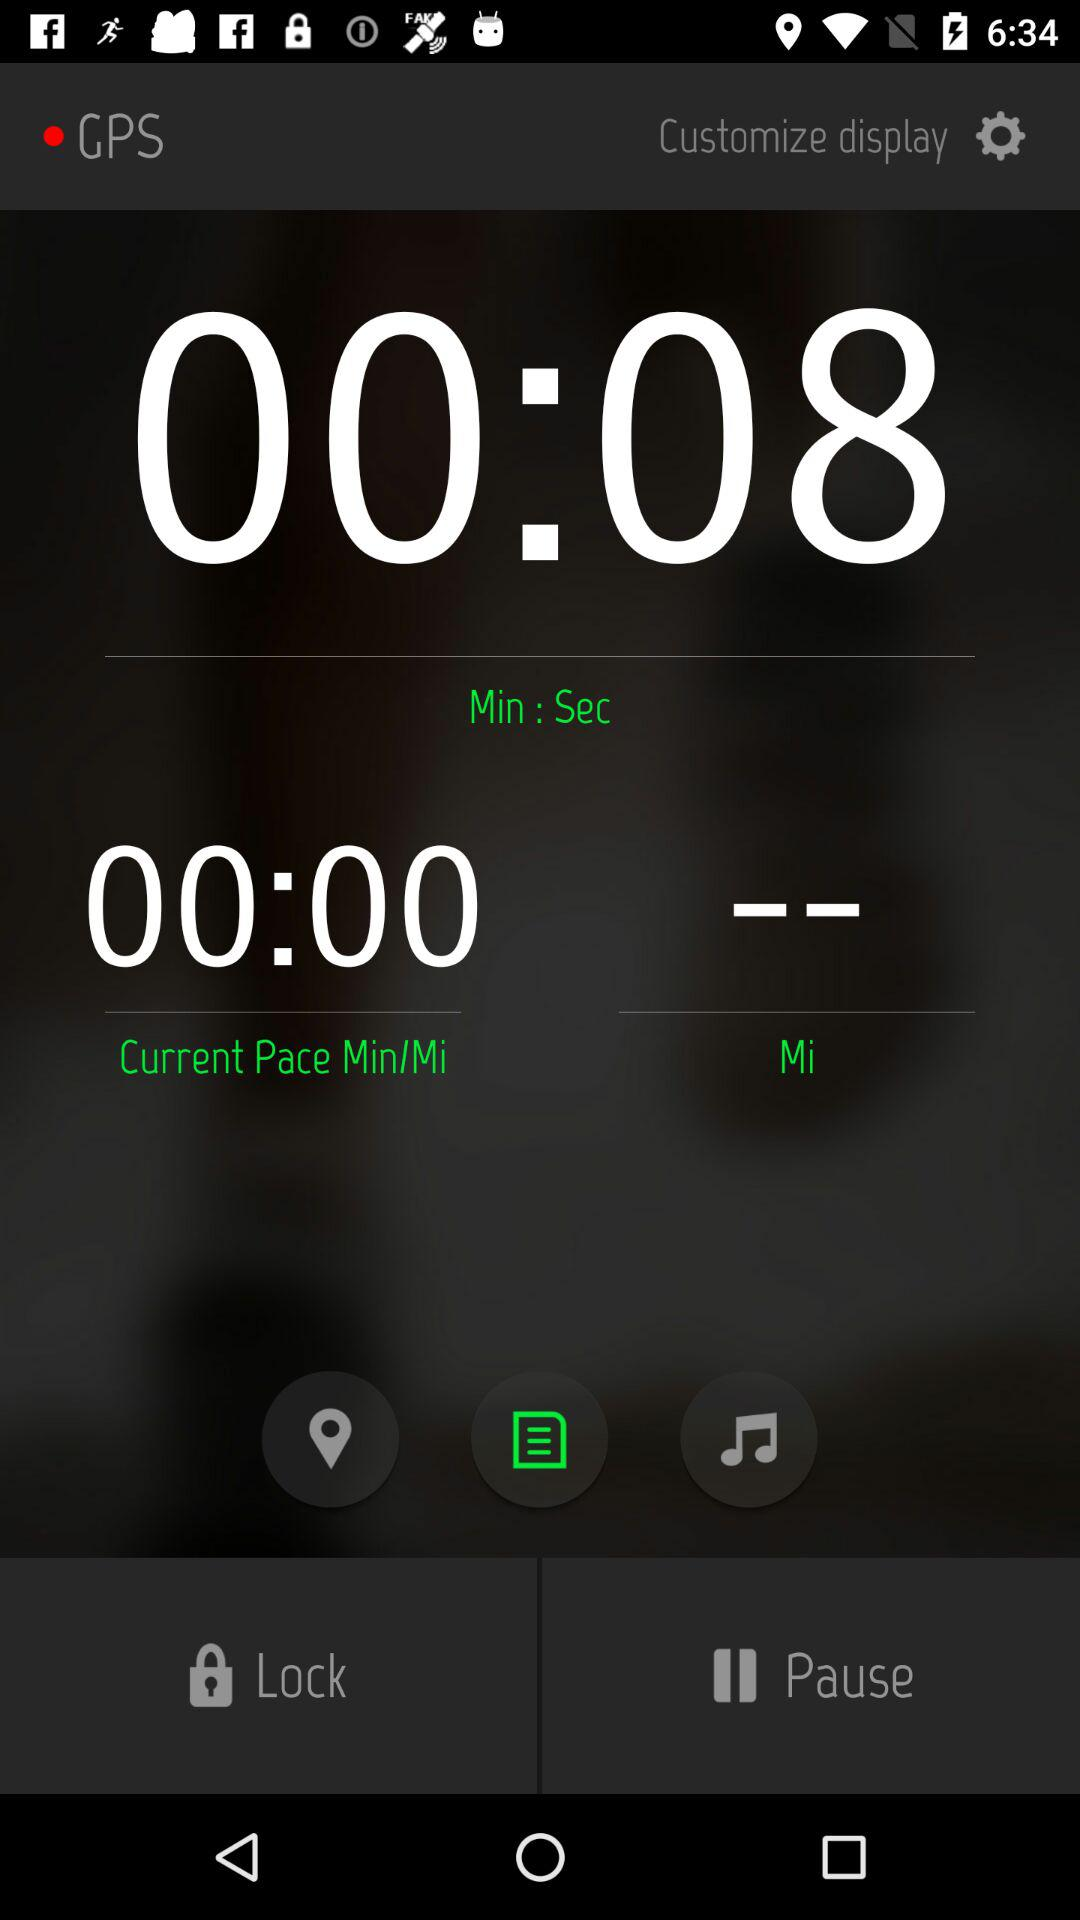What is the time duration? The time duration is 8 seconds. 